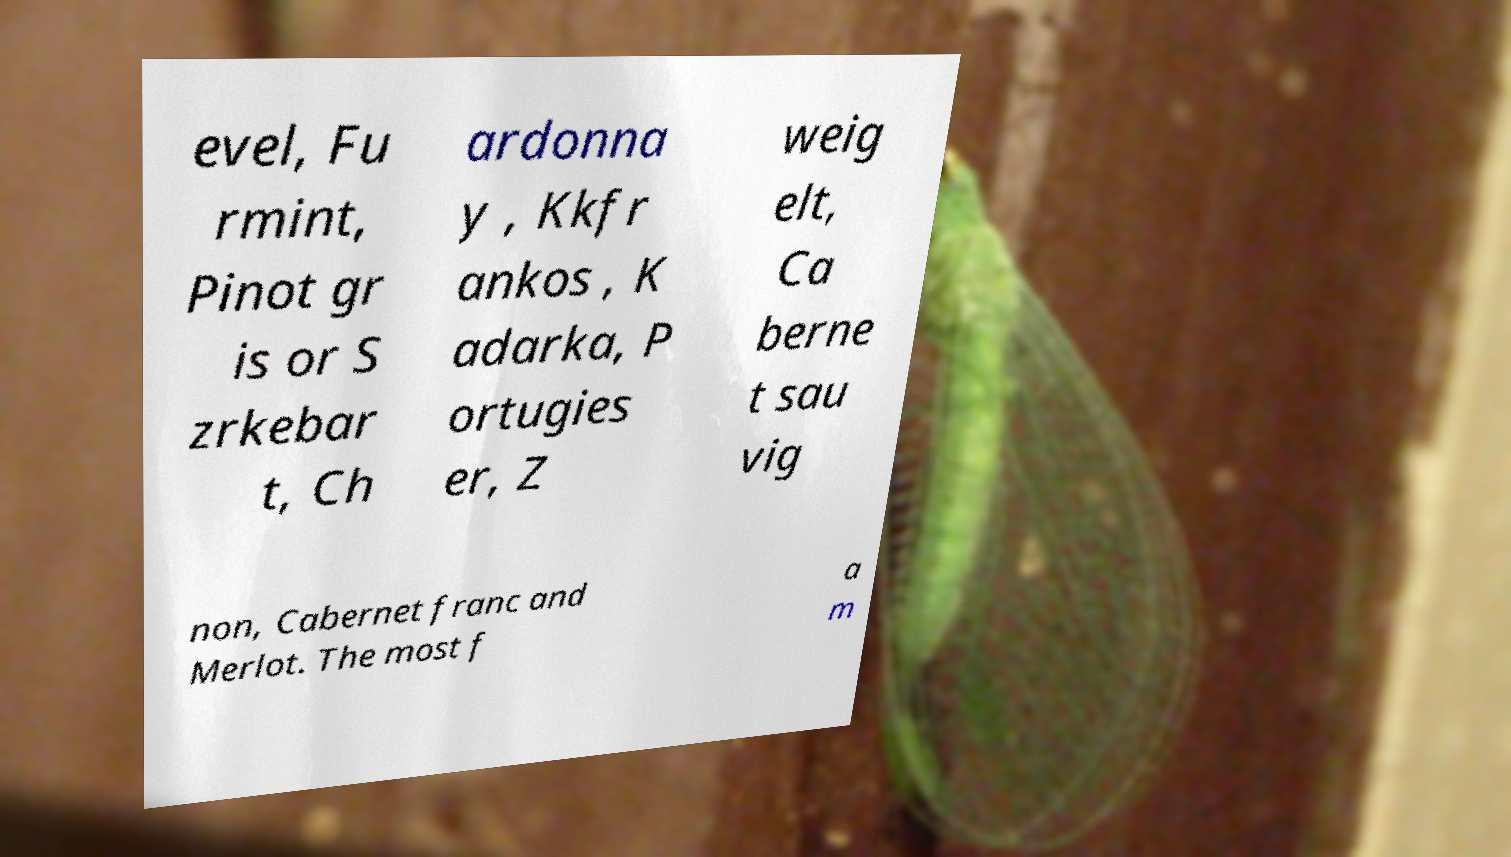Please read and relay the text visible in this image. What does it say? evel, Fu rmint, Pinot gr is or S zrkebar t, Ch ardonna y , Kkfr ankos , K adarka, P ortugies er, Z weig elt, Ca berne t sau vig non, Cabernet franc and Merlot. The most f a m 